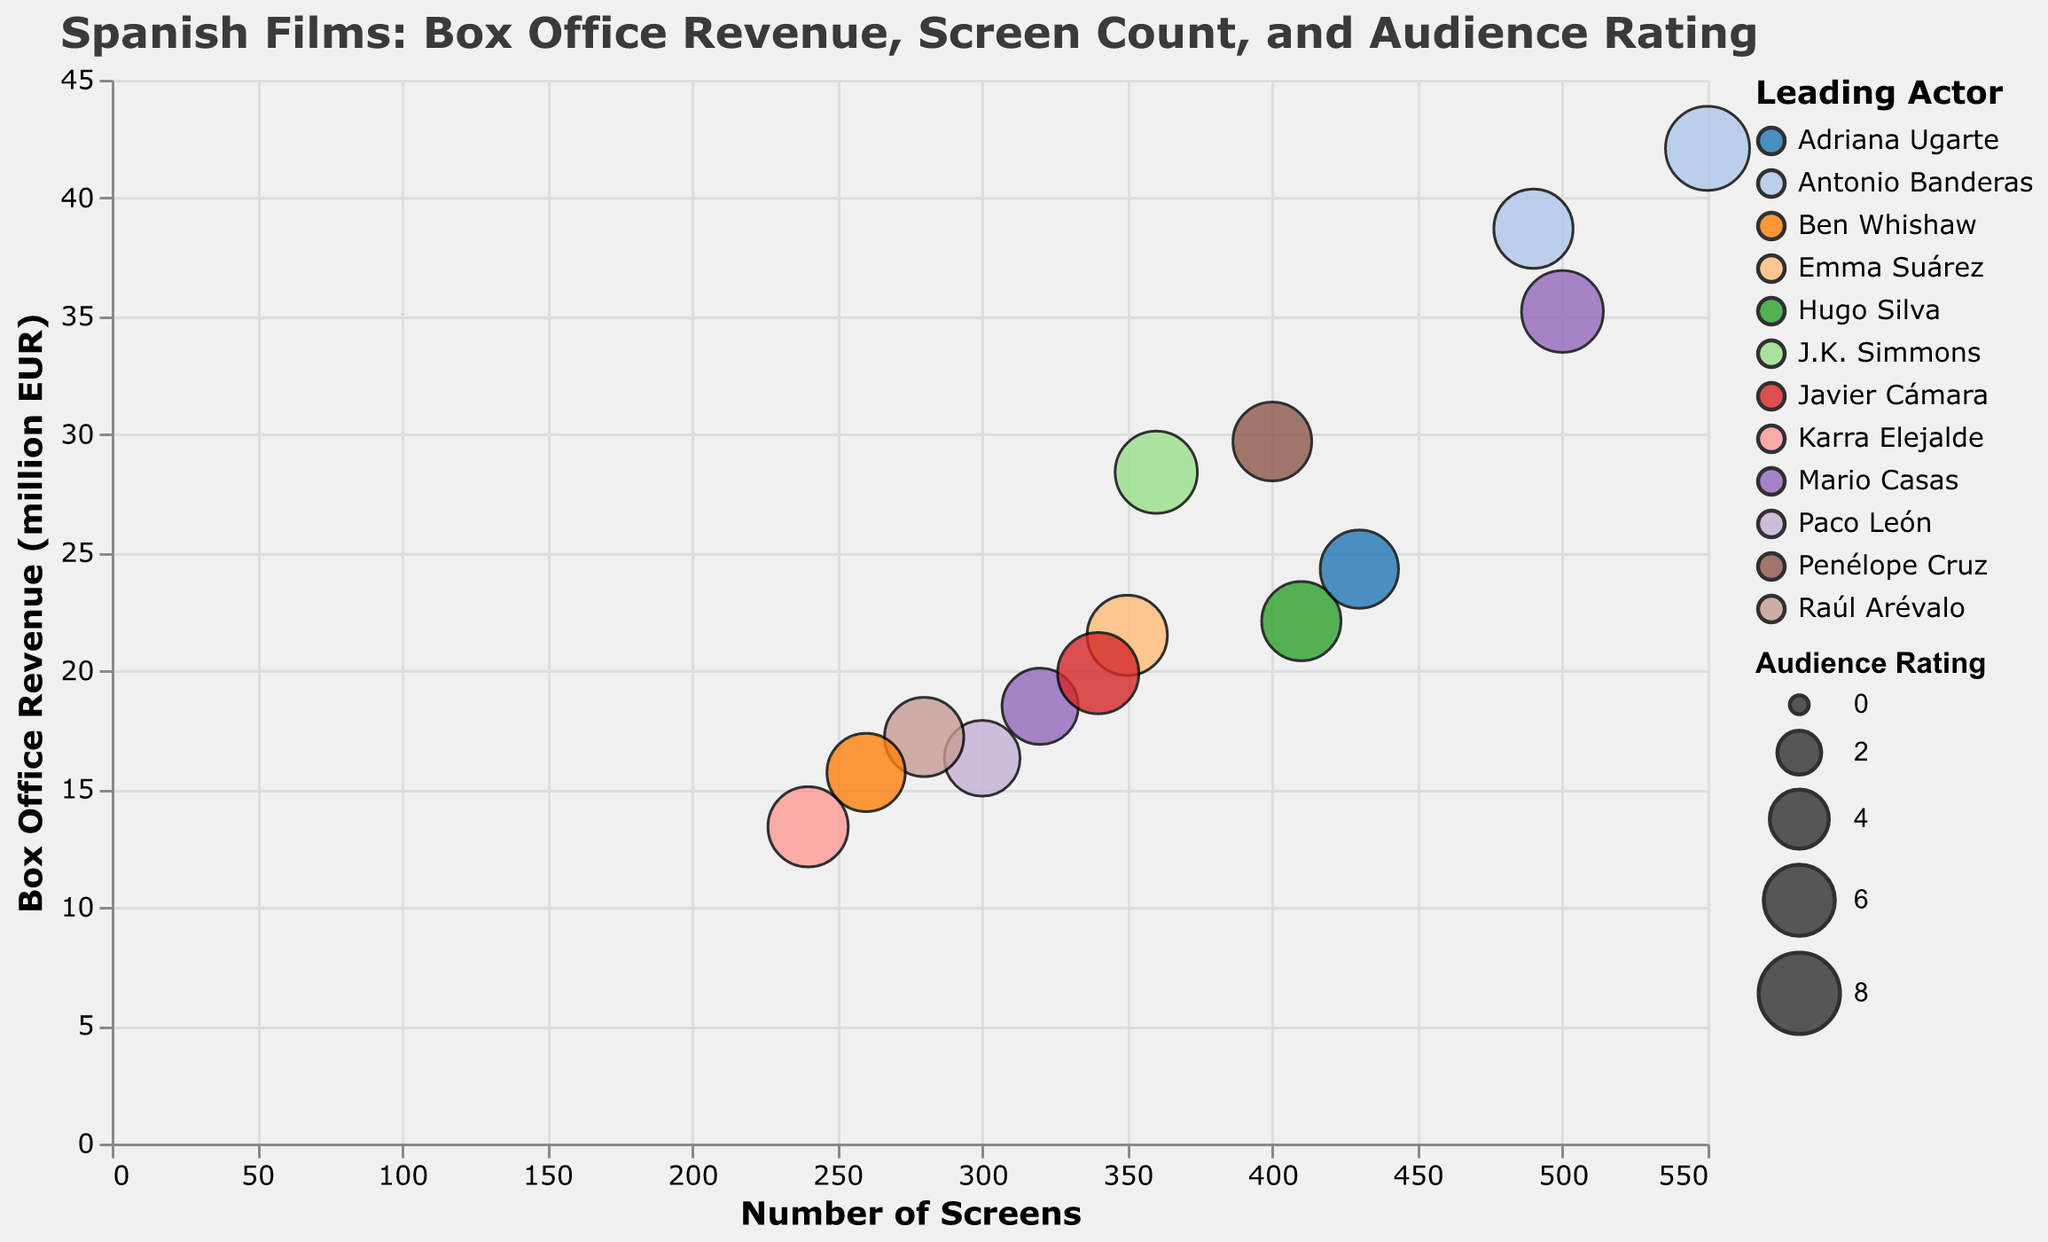What is the film with the highest box office revenue? The figure shows that "Pain and Glory," starring Antonio Banderas, has the highest box office revenue, placed at the highest position on the y-axis.
Answer: Pain and Glory Which actor stars in two films, and what are those films? By examining the different color sections and identifying the actor, Mario Casas stars in both "The Invisible Guest" and "Palm Trees in the Snow."
Answer: Mario Casas, The Invisible Guest, Palm Trees in the Snow How many films have an audience rating greater than 8? By examining the size of the bubbles and checking those with a larger size indicating higher ratings, there are four films: "The Invisible Guest," "Truman," "Klaus," and "Pain and Glory."
Answer: 4 What is the average box office revenue of Mario Casas's films? Calculate the box office revenue for "The Invisible Guest" (35.2) and "Palm Trees in the Snow" (18.5). Add them together (35.2 + 18.5 = 53.7) and divide by 2 to get the average.
Answer: 26.85 million EUR Which film has the highest audience rating and what is it? Identify the largest bubble in terms of size as it represents the audience rating. The film is "Pain and Glory" with an audience rating of 8.6.
Answer: Pain and Glory, 8.6 What is the difference in box office revenue between "The Invisible Guest" and "While at War"? Find the y-axis value for both films (35.2 for "The Invisible Guest" and 13.4 for "While at War") and subtract the smaller from the larger: 35.2 - 13.4.
Answer: 21.8 million EUR Which film has the highest number of screens and how many screens is it? The x-axis shows the number of screens; look at the farthest right point. "Pain and Glory" has the highest screens with 550.
Answer: Pain and Glory, 550 